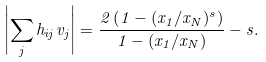Convert formula to latex. <formula><loc_0><loc_0><loc_500><loc_500>\left | \sum _ { j } h _ { i j } v _ { j } \right | = \frac { 2 \left ( 1 - ( { x _ { 1 } } / { x _ { N } } ) ^ { s } \right ) } { 1 - ( { x _ { 1 } } / { x _ { N } } ) } - s .</formula> 